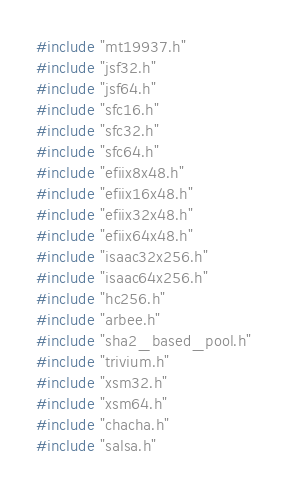<code> <loc_0><loc_0><loc_500><loc_500><_C_>
#include "mt19937.h"
#include "jsf32.h"
#include "jsf64.h"
#include "sfc16.h"
#include "sfc32.h"
#include "sfc64.h"
#include "efiix8x48.h"
#include "efiix16x48.h"
#include "efiix32x48.h"
#include "efiix64x48.h"
#include "isaac32x256.h"
#include "isaac64x256.h"
#include "hc256.h"
#include "arbee.h"
#include "sha2_based_pool.h"
#include "trivium.h"
#include "xsm32.h"
#include "xsm64.h"
#include "chacha.h"
#include "salsa.h"

</code> 